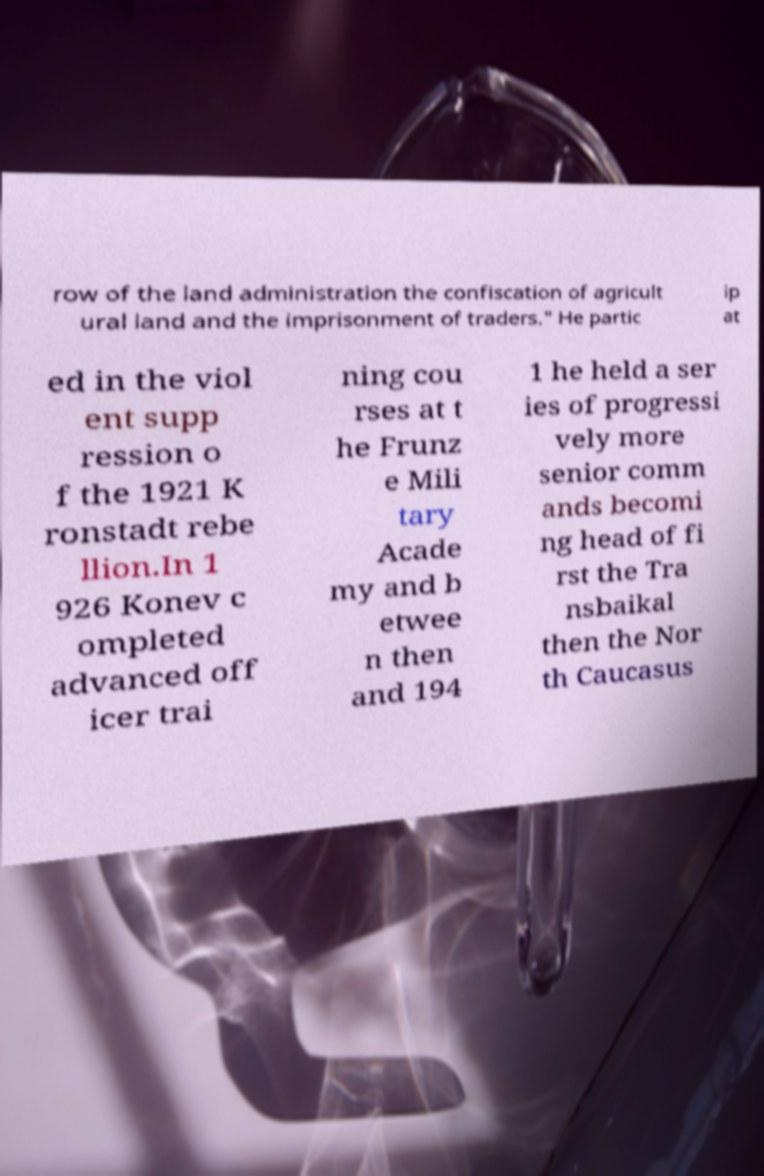There's text embedded in this image that I need extracted. Can you transcribe it verbatim? row of the land administration the confiscation of agricult ural land and the imprisonment of traders." He partic ip at ed in the viol ent supp ression o f the 1921 K ronstadt rebe llion.In 1 926 Konev c ompleted advanced off icer trai ning cou rses at t he Frunz e Mili tary Acade my and b etwee n then and 194 1 he held a ser ies of progressi vely more senior comm ands becomi ng head of fi rst the Tra nsbaikal then the Nor th Caucasus 